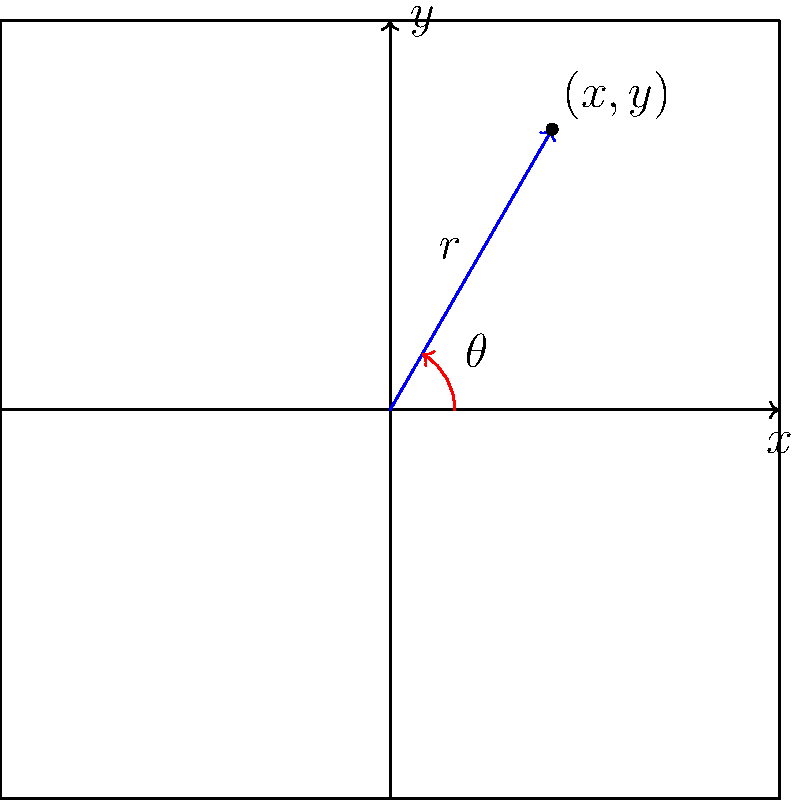A new radar system interface at our electronics store displays target locations in polar coordinates $(r,\theta)$. However, the tracking software requires rectangular coordinates $(x,y)$. A target is detected at $(5,\frac{\pi}{3})$ in polar coordinates. What are the corresponding rectangular coordinates for this target? To convert from polar coordinates $(r,\theta)$ to rectangular coordinates $(x,y)$, we use the following formulas:

1) $x = r \cos(\theta)$
2) $y = r \sin(\theta)$

Given:
- $r = 5$
- $\theta = \frac{\pi}{3}$

Step 1: Calculate x
$x = r \cos(\theta) = 5 \cos(\frac{\pi}{3})$
$\cos(\frac{\pi}{3}) = \frac{1}{2}$
$x = 5 \cdot \frac{1}{2} = 2.5$

Step 2: Calculate y
$y = r \sin(\theta) = 5 \sin(\frac{\pi}{3})$
$\sin(\frac{\pi}{3}) = \frac{\sqrt{3}}{2}$
$y = 5 \cdot \frac{\sqrt{3}}{2} = \frac{5\sqrt{3}}{2} \approx 4.33$

Therefore, the rectangular coordinates are $(2.5, \frac{5\sqrt{3}}{2})$ or approximately $(2.5, 4.33)$.
Answer: $(2.5, \frac{5\sqrt{3}}{2})$ 